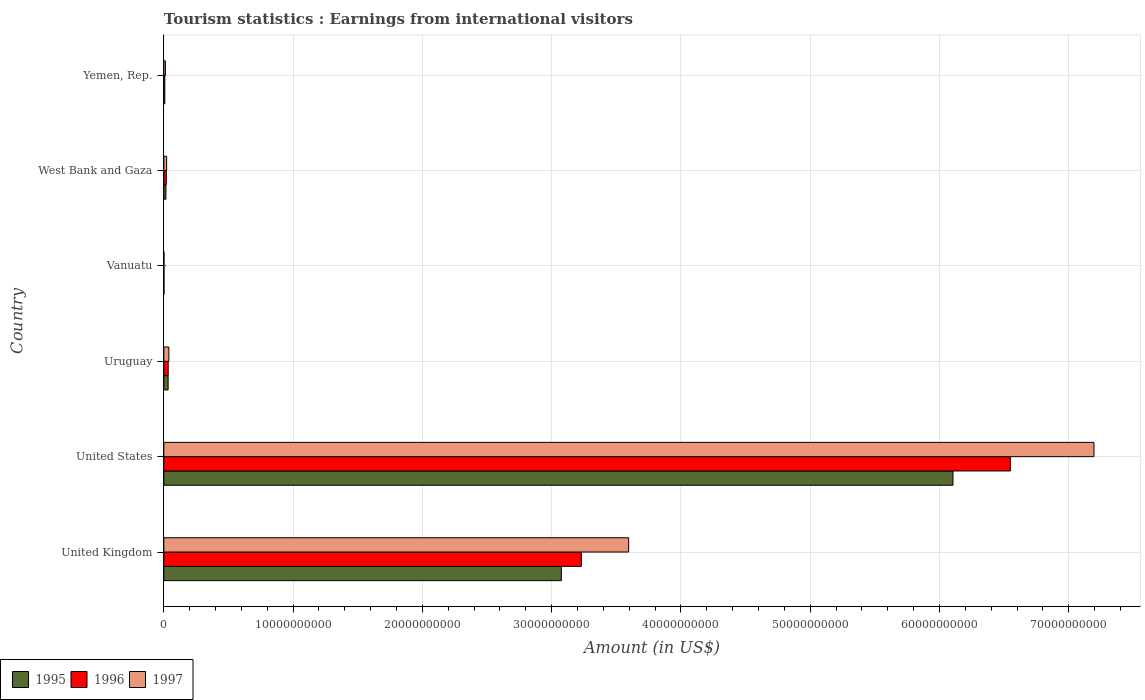How many groups of bars are there?
Make the answer very short. 6. Are the number of bars per tick equal to the number of legend labels?
Provide a short and direct response. Yes. Are the number of bars on each tick of the Y-axis equal?
Make the answer very short. Yes. How many bars are there on the 6th tick from the top?
Provide a short and direct response. 3. What is the label of the 5th group of bars from the top?
Your answer should be very brief. United States. What is the earnings from international visitors in 1995 in United Kingdom?
Your response must be concise. 3.07e+1. Across all countries, what is the maximum earnings from international visitors in 1995?
Make the answer very short. 6.10e+1. Across all countries, what is the minimum earnings from international visitors in 1996?
Offer a terse response. 1.00e+07. In which country was the earnings from international visitors in 1997 maximum?
Your answer should be very brief. United States. In which country was the earnings from international visitors in 1996 minimum?
Make the answer very short. Vanuatu. What is the total earnings from international visitors in 1996 in the graph?
Your response must be concise. 9.84e+1. What is the difference between the earnings from international visitors in 1997 in Vanuatu and that in West Bank and Gaza?
Provide a succinct answer. -2.08e+08. What is the difference between the earnings from international visitors in 1995 in United Kingdom and the earnings from international visitors in 1997 in Uruguay?
Your answer should be compact. 3.04e+1. What is the average earnings from international visitors in 1995 per country?
Give a very brief answer. 1.54e+1. What is the ratio of the earnings from international visitors in 1996 in United States to that in West Bank and Gaza?
Your answer should be very brief. 342.81. Is the earnings from international visitors in 1997 in United States less than that in Vanuatu?
Provide a short and direct response. No. What is the difference between the highest and the second highest earnings from international visitors in 1997?
Ensure brevity in your answer.  3.60e+1. What is the difference between the highest and the lowest earnings from international visitors in 1995?
Ensure brevity in your answer.  6.10e+1. In how many countries, is the earnings from international visitors in 1995 greater than the average earnings from international visitors in 1995 taken over all countries?
Your response must be concise. 2. Is the sum of the earnings from international visitors in 1997 in Vanuatu and Yemen, Rep. greater than the maximum earnings from international visitors in 1996 across all countries?
Offer a very short reply. No. Is it the case that in every country, the sum of the earnings from international visitors in 1995 and earnings from international visitors in 1997 is greater than the earnings from international visitors in 1996?
Offer a very short reply. Yes. Are all the bars in the graph horizontal?
Ensure brevity in your answer.  Yes. Are the values on the major ticks of X-axis written in scientific E-notation?
Provide a short and direct response. No. Does the graph contain grids?
Your answer should be compact. Yes. Where does the legend appear in the graph?
Your response must be concise. Bottom left. How many legend labels are there?
Offer a terse response. 3. How are the legend labels stacked?
Provide a succinct answer. Horizontal. What is the title of the graph?
Make the answer very short. Tourism statistics : Earnings from international visitors. What is the label or title of the X-axis?
Make the answer very short. Amount (in US$). What is the label or title of the Y-axis?
Give a very brief answer. Country. What is the Amount (in US$) of 1995 in United Kingdom?
Keep it short and to the point. 3.07e+1. What is the Amount (in US$) of 1996 in United Kingdom?
Ensure brevity in your answer.  3.23e+1. What is the Amount (in US$) of 1997 in United Kingdom?
Provide a succinct answer. 3.60e+1. What is the Amount (in US$) in 1995 in United States?
Your answer should be very brief. 6.10e+1. What is the Amount (in US$) in 1996 in United States?
Give a very brief answer. 6.55e+1. What is the Amount (in US$) of 1997 in United States?
Ensure brevity in your answer.  7.19e+1. What is the Amount (in US$) of 1995 in Uruguay?
Provide a short and direct response. 3.32e+08. What is the Amount (in US$) in 1996 in Uruguay?
Provide a short and direct response. 3.39e+08. What is the Amount (in US$) of 1997 in Uruguay?
Make the answer very short. 3.91e+08. What is the Amount (in US$) in 1995 in West Bank and Gaza?
Your answer should be compact. 1.62e+08. What is the Amount (in US$) of 1996 in West Bank and Gaza?
Provide a succinct answer. 1.91e+08. What is the Amount (in US$) of 1997 in West Bank and Gaza?
Offer a terse response. 2.18e+08. What is the Amount (in US$) of 1995 in Yemen, Rep.?
Provide a succinct answer. 7.60e+07. What is the Amount (in US$) of 1996 in Yemen, Rep.?
Provide a succinct answer. 7.80e+07. What is the Amount (in US$) in 1997 in Yemen, Rep.?
Your answer should be very brief. 1.24e+08. Across all countries, what is the maximum Amount (in US$) in 1995?
Your answer should be compact. 6.10e+1. Across all countries, what is the maximum Amount (in US$) of 1996?
Your response must be concise. 6.55e+1. Across all countries, what is the maximum Amount (in US$) of 1997?
Make the answer very short. 7.19e+1. Across all countries, what is the minimum Amount (in US$) in 1995?
Provide a short and direct response. 1.00e+07. Across all countries, what is the minimum Amount (in US$) of 1996?
Keep it short and to the point. 1.00e+07. What is the total Amount (in US$) in 1995 in the graph?
Offer a very short reply. 9.24e+1. What is the total Amount (in US$) of 1996 in the graph?
Make the answer very short. 9.84e+1. What is the total Amount (in US$) in 1997 in the graph?
Your answer should be compact. 1.09e+11. What is the difference between the Amount (in US$) in 1995 in United Kingdom and that in United States?
Give a very brief answer. -3.03e+1. What is the difference between the Amount (in US$) of 1996 in United Kingdom and that in United States?
Keep it short and to the point. -3.32e+1. What is the difference between the Amount (in US$) in 1997 in United Kingdom and that in United States?
Offer a very short reply. -3.60e+1. What is the difference between the Amount (in US$) in 1995 in United Kingdom and that in Uruguay?
Make the answer very short. 3.04e+1. What is the difference between the Amount (in US$) in 1996 in United Kingdom and that in Uruguay?
Offer a very short reply. 3.20e+1. What is the difference between the Amount (in US$) in 1997 in United Kingdom and that in Uruguay?
Ensure brevity in your answer.  3.56e+1. What is the difference between the Amount (in US$) of 1995 in United Kingdom and that in Vanuatu?
Provide a succinct answer. 3.07e+1. What is the difference between the Amount (in US$) of 1996 in United Kingdom and that in Vanuatu?
Ensure brevity in your answer.  3.23e+1. What is the difference between the Amount (in US$) in 1997 in United Kingdom and that in Vanuatu?
Keep it short and to the point. 3.59e+1. What is the difference between the Amount (in US$) in 1995 in United Kingdom and that in West Bank and Gaza?
Keep it short and to the point. 3.06e+1. What is the difference between the Amount (in US$) in 1996 in United Kingdom and that in West Bank and Gaza?
Keep it short and to the point. 3.21e+1. What is the difference between the Amount (in US$) of 1997 in United Kingdom and that in West Bank and Gaza?
Make the answer very short. 3.57e+1. What is the difference between the Amount (in US$) of 1995 in United Kingdom and that in Yemen, Rep.?
Your response must be concise. 3.07e+1. What is the difference between the Amount (in US$) in 1996 in United Kingdom and that in Yemen, Rep.?
Provide a short and direct response. 3.22e+1. What is the difference between the Amount (in US$) in 1997 in United Kingdom and that in Yemen, Rep.?
Your response must be concise. 3.58e+1. What is the difference between the Amount (in US$) in 1995 in United States and that in Uruguay?
Offer a terse response. 6.07e+1. What is the difference between the Amount (in US$) in 1996 in United States and that in Uruguay?
Offer a very short reply. 6.51e+1. What is the difference between the Amount (in US$) in 1997 in United States and that in Uruguay?
Ensure brevity in your answer.  7.16e+1. What is the difference between the Amount (in US$) in 1995 in United States and that in Vanuatu?
Ensure brevity in your answer.  6.10e+1. What is the difference between the Amount (in US$) in 1996 in United States and that in Vanuatu?
Offer a very short reply. 6.55e+1. What is the difference between the Amount (in US$) in 1997 in United States and that in Vanuatu?
Provide a short and direct response. 7.19e+1. What is the difference between the Amount (in US$) in 1995 in United States and that in West Bank and Gaza?
Your answer should be compact. 6.09e+1. What is the difference between the Amount (in US$) of 1996 in United States and that in West Bank and Gaza?
Your answer should be compact. 6.53e+1. What is the difference between the Amount (in US$) of 1997 in United States and that in West Bank and Gaza?
Provide a short and direct response. 7.17e+1. What is the difference between the Amount (in US$) of 1995 in United States and that in Yemen, Rep.?
Offer a terse response. 6.10e+1. What is the difference between the Amount (in US$) in 1996 in United States and that in Yemen, Rep.?
Make the answer very short. 6.54e+1. What is the difference between the Amount (in US$) of 1997 in United States and that in Yemen, Rep.?
Your answer should be very brief. 7.18e+1. What is the difference between the Amount (in US$) in 1995 in Uruguay and that in Vanuatu?
Your answer should be very brief. 3.22e+08. What is the difference between the Amount (in US$) of 1996 in Uruguay and that in Vanuatu?
Ensure brevity in your answer.  3.29e+08. What is the difference between the Amount (in US$) of 1997 in Uruguay and that in Vanuatu?
Provide a succinct answer. 3.81e+08. What is the difference between the Amount (in US$) of 1995 in Uruguay and that in West Bank and Gaza?
Your answer should be very brief. 1.70e+08. What is the difference between the Amount (in US$) in 1996 in Uruguay and that in West Bank and Gaza?
Keep it short and to the point. 1.48e+08. What is the difference between the Amount (in US$) of 1997 in Uruguay and that in West Bank and Gaza?
Your answer should be compact. 1.73e+08. What is the difference between the Amount (in US$) in 1995 in Uruguay and that in Yemen, Rep.?
Ensure brevity in your answer.  2.56e+08. What is the difference between the Amount (in US$) of 1996 in Uruguay and that in Yemen, Rep.?
Your response must be concise. 2.61e+08. What is the difference between the Amount (in US$) in 1997 in Uruguay and that in Yemen, Rep.?
Give a very brief answer. 2.67e+08. What is the difference between the Amount (in US$) in 1995 in Vanuatu and that in West Bank and Gaza?
Provide a succinct answer. -1.52e+08. What is the difference between the Amount (in US$) in 1996 in Vanuatu and that in West Bank and Gaza?
Make the answer very short. -1.81e+08. What is the difference between the Amount (in US$) in 1997 in Vanuatu and that in West Bank and Gaza?
Ensure brevity in your answer.  -2.08e+08. What is the difference between the Amount (in US$) in 1995 in Vanuatu and that in Yemen, Rep.?
Provide a succinct answer. -6.60e+07. What is the difference between the Amount (in US$) of 1996 in Vanuatu and that in Yemen, Rep.?
Keep it short and to the point. -6.80e+07. What is the difference between the Amount (in US$) in 1997 in Vanuatu and that in Yemen, Rep.?
Ensure brevity in your answer.  -1.14e+08. What is the difference between the Amount (in US$) of 1995 in West Bank and Gaza and that in Yemen, Rep.?
Give a very brief answer. 8.60e+07. What is the difference between the Amount (in US$) in 1996 in West Bank and Gaza and that in Yemen, Rep.?
Provide a succinct answer. 1.13e+08. What is the difference between the Amount (in US$) in 1997 in West Bank and Gaza and that in Yemen, Rep.?
Ensure brevity in your answer.  9.40e+07. What is the difference between the Amount (in US$) in 1995 in United Kingdom and the Amount (in US$) in 1996 in United States?
Keep it short and to the point. -3.47e+1. What is the difference between the Amount (in US$) in 1995 in United Kingdom and the Amount (in US$) in 1997 in United States?
Keep it short and to the point. -4.12e+1. What is the difference between the Amount (in US$) in 1996 in United Kingdom and the Amount (in US$) in 1997 in United States?
Make the answer very short. -3.97e+1. What is the difference between the Amount (in US$) of 1995 in United Kingdom and the Amount (in US$) of 1996 in Uruguay?
Offer a very short reply. 3.04e+1. What is the difference between the Amount (in US$) of 1995 in United Kingdom and the Amount (in US$) of 1997 in Uruguay?
Provide a succinct answer. 3.04e+1. What is the difference between the Amount (in US$) of 1996 in United Kingdom and the Amount (in US$) of 1997 in Uruguay?
Give a very brief answer. 3.19e+1. What is the difference between the Amount (in US$) of 1995 in United Kingdom and the Amount (in US$) of 1996 in Vanuatu?
Your answer should be very brief. 3.07e+1. What is the difference between the Amount (in US$) of 1995 in United Kingdom and the Amount (in US$) of 1997 in Vanuatu?
Ensure brevity in your answer.  3.07e+1. What is the difference between the Amount (in US$) of 1996 in United Kingdom and the Amount (in US$) of 1997 in Vanuatu?
Your answer should be compact. 3.23e+1. What is the difference between the Amount (in US$) of 1995 in United Kingdom and the Amount (in US$) of 1996 in West Bank and Gaza?
Keep it short and to the point. 3.06e+1. What is the difference between the Amount (in US$) in 1995 in United Kingdom and the Amount (in US$) in 1997 in West Bank and Gaza?
Your answer should be very brief. 3.05e+1. What is the difference between the Amount (in US$) in 1996 in United Kingdom and the Amount (in US$) in 1997 in West Bank and Gaza?
Your response must be concise. 3.21e+1. What is the difference between the Amount (in US$) of 1995 in United Kingdom and the Amount (in US$) of 1996 in Yemen, Rep.?
Provide a short and direct response. 3.07e+1. What is the difference between the Amount (in US$) of 1995 in United Kingdom and the Amount (in US$) of 1997 in Yemen, Rep.?
Provide a short and direct response. 3.06e+1. What is the difference between the Amount (in US$) of 1996 in United Kingdom and the Amount (in US$) of 1997 in Yemen, Rep.?
Give a very brief answer. 3.22e+1. What is the difference between the Amount (in US$) in 1995 in United States and the Amount (in US$) in 1996 in Uruguay?
Offer a terse response. 6.07e+1. What is the difference between the Amount (in US$) of 1995 in United States and the Amount (in US$) of 1997 in Uruguay?
Ensure brevity in your answer.  6.07e+1. What is the difference between the Amount (in US$) in 1996 in United States and the Amount (in US$) in 1997 in Uruguay?
Offer a very short reply. 6.51e+1. What is the difference between the Amount (in US$) of 1995 in United States and the Amount (in US$) of 1996 in Vanuatu?
Make the answer very short. 6.10e+1. What is the difference between the Amount (in US$) of 1995 in United States and the Amount (in US$) of 1997 in Vanuatu?
Your answer should be very brief. 6.10e+1. What is the difference between the Amount (in US$) of 1996 in United States and the Amount (in US$) of 1997 in Vanuatu?
Keep it short and to the point. 6.55e+1. What is the difference between the Amount (in US$) of 1995 in United States and the Amount (in US$) of 1996 in West Bank and Gaza?
Keep it short and to the point. 6.09e+1. What is the difference between the Amount (in US$) of 1995 in United States and the Amount (in US$) of 1997 in West Bank and Gaza?
Your response must be concise. 6.08e+1. What is the difference between the Amount (in US$) of 1996 in United States and the Amount (in US$) of 1997 in West Bank and Gaza?
Your response must be concise. 6.53e+1. What is the difference between the Amount (in US$) in 1995 in United States and the Amount (in US$) in 1996 in Yemen, Rep.?
Provide a short and direct response. 6.10e+1. What is the difference between the Amount (in US$) of 1995 in United States and the Amount (in US$) of 1997 in Yemen, Rep.?
Your response must be concise. 6.09e+1. What is the difference between the Amount (in US$) of 1996 in United States and the Amount (in US$) of 1997 in Yemen, Rep.?
Offer a very short reply. 6.54e+1. What is the difference between the Amount (in US$) of 1995 in Uruguay and the Amount (in US$) of 1996 in Vanuatu?
Your answer should be very brief. 3.22e+08. What is the difference between the Amount (in US$) of 1995 in Uruguay and the Amount (in US$) of 1997 in Vanuatu?
Keep it short and to the point. 3.22e+08. What is the difference between the Amount (in US$) in 1996 in Uruguay and the Amount (in US$) in 1997 in Vanuatu?
Provide a succinct answer. 3.29e+08. What is the difference between the Amount (in US$) in 1995 in Uruguay and the Amount (in US$) in 1996 in West Bank and Gaza?
Your answer should be very brief. 1.41e+08. What is the difference between the Amount (in US$) in 1995 in Uruguay and the Amount (in US$) in 1997 in West Bank and Gaza?
Keep it short and to the point. 1.14e+08. What is the difference between the Amount (in US$) of 1996 in Uruguay and the Amount (in US$) of 1997 in West Bank and Gaza?
Give a very brief answer. 1.21e+08. What is the difference between the Amount (in US$) of 1995 in Uruguay and the Amount (in US$) of 1996 in Yemen, Rep.?
Offer a terse response. 2.54e+08. What is the difference between the Amount (in US$) in 1995 in Uruguay and the Amount (in US$) in 1997 in Yemen, Rep.?
Provide a succinct answer. 2.08e+08. What is the difference between the Amount (in US$) in 1996 in Uruguay and the Amount (in US$) in 1997 in Yemen, Rep.?
Offer a very short reply. 2.15e+08. What is the difference between the Amount (in US$) of 1995 in Vanuatu and the Amount (in US$) of 1996 in West Bank and Gaza?
Ensure brevity in your answer.  -1.81e+08. What is the difference between the Amount (in US$) of 1995 in Vanuatu and the Amount (in US$) of 1997 in West Bank and Gaza?
Make the answer very short. -2.08e+08. What is the difference between the Amount (in US$) of 1996 in Vanuatu and the Amount (in US$) of 1997 in West Bank and Gaza?
Offer a terse response. -2.08e+08. What is the difference between the Amount (in US$) in 1995 in Vanuatu and the Amount (in US$) in 1996 in Yemen, Rep.?
Your response must be concise. -6.80e+07. What is the difference between the Amount (in US$) in 1995 in Vanuatu and the Amount (in US$) in 1997 in Yemen, Rep.?
Provide a succinct answer. -1.14e+08. What is the difference between the Amount (in US$) in 1996 in Vanuatu and the Amount (in US$) in 1997 in Yemen, Rep.?
Keep it short and to the point. -1.14e+08. What is the difference between the Amount (in US$) of 1995 in West Bank and Gaza and the Amount (in US$) of 1996 in Yemen, Rep.?
Offer a terse response. 8.40e+07. What is the difference between the Amount (in US$) of 1995 in West Bank and Gaza and the Amount (in US$) of 1997 in Yemen, Rep.?
Offer a terse response. 3.80e+07. What is the difference between the Amount (in US$) of 1996 in West Bank and Gaza and the Amount (in US$) of 1997 in Yemen, Rep.?
Keep it short and to the point. 6.70e+07. What is the average Amount (in US$) of 1995 per country?
Ensure brevity in your answer.  1.54e+1. What is the average Amount (in US$) of 1996 per country?
Provide a short and direct response. 1.64e+1. What is the average Amount (in US$) in 1997 per country?
Offer a very short reply. 1.81e+1. What is the difference between the Amount (in US$) in 1995 and Amount (in US$) in 1996 in United Kingdom?
Give a very brief answer. -1.55e+09. What is the difference between the Amount (in US$) of 1995 and Amount (in US$) of 1997 in United Kingdom?
Your answer should be very brief. -5.20e+09. What is the difference between the Amount (in US$) in 1996 and Amount (in US$) in 1997 in United Kingdom?
Provide a succinct answer. -3.66e+09. What is the difference between the Amount (in US$) in 1995 and Amount (in US$) in 1996 in United States?
Your response must be concise. -4.44e+09. What is the difference between the Amount (in US$) in 1995 and Amount (in US$) in 1997 in United States?
Your answer should be very brief. -1.09e+1. What is the difference between the Amount (in US$) in 1996 and Amount (in US$) in 1997 in United States?
Provide a short and direct response. -6.47e+09. What is the difference between the Amount (in US$) in 1995 and Amount (in US$) in 1996 in Uruguay?
Your answer should be very brief. -7.00e+06. What is the difference between the Amount (in US$) in 1995 and Amount (in US$) in 1997 in Uruguay?
Offer a terse response. -5.90e+07. What is the difference between the Amount (in US$) of 1996 and Amount (in US$) of 1997 in Uruguay?
Offer a very short reply. -5.20e+07. What is the difference between the Amount (in US$) in 1996 and Amount (in US$) in 1997 in Vanuatu?
Your response must be concise. 0. What is the difference between the Amount (in US$) of 1995 and Amount (in US$) of 1996 in West Bank and Gaza?
Your response must be concise. -2.90e+07. What is the difference between the Amount (in US$) of 1995 and Amount (in US$) of 1997 in West Bank and Gaza?
Offer a very short reply. -5.60e+07. What is the difference between the Amount (in US$) of 1996 and Amount (in US$) of 1997 in West Bank and Gaza?
Keep it short and to the point. -2.70e+07. What is the difference between the Amount (in US$) in 1995 and Amount (in US$) in 1996 in Yemen, Rep.?
Provide a short and direct response. -2.00e+06. What is the difference between the Amount (in US$) in 1995 and Amount (in US$) in 1997 in Yemen, Rep.?
Your answer should be very brief. -4.80e+07. What is the difference between the Amount (in US$) in 1996 and Amount (in US$) in 1997 in Yemen, Rep.?
Your response must be concise. -4.60e+07. What is the ratio of the Amount (in US$) of 1995 in United Kingdom to that in United States?
Ensure brevity in your answer.  0.5. What is the ratio of the Amount (in US$) in 1996 in United Kingdom to that in United States?
Provide a short and direct response. 0.49. What is the ratio of the Amount (in US$) in 1997 in United Kingdom to that in United States?
Provide a short and direct response. 0.5. What is the ratio of the Amount (in US$) in 1995 in United Kingdom to that in Uruguay?
Keep it short and to the point. 92.62. What is the ratio of the Amount (in US$) of 1996 in United Kingdom to that in Uruguay?
Offer a terse response. 95.27. What is the ratio of the Amount (in US$) of 1997 in United Kingdom to that in Uruguay?
Ensure brevity in your answer.  91.95. What is the ratio of the Amount (in US$) in 1995 in United Kingdom to that in Vanuatu?
Provide a succinct answer. 3074.9. What is the ratio of the Amount (in US$) of 1996 in United Kingdom to that in Vanuatu?
Provide a succinct answer. 3229.79. What is the ratio of the Amount (in US$) of 1997 in United Kingdom to that in Vanuatu?
Your response must be concise. 3595.4. What is the ratio of the Amount (in US$) of 1995 in United Kingdom to that in West Bank and Gaza?
Your answer should be compact. 189.81. What is the ratio of the Amount (in US$) in 1996 in United Kingdom to that in West Bank and Gaza?
Offer a terse response. 169.1. What is the ratio of the Amount (in US$) in 1997 in United Kingdom to that in West Bank and Gaza?
Keep it short and to the point. 164.93. What is the ratio of the Amount (in US$) in 1995 in United Kingdom to that in Yemen, Rep.?
Make the answer very short. 404.59. What is the ratio of the Amount (in US$) in 1996 in United Kingdom to that in Yemen, Rep.?
Provide a short and direct response. 414.08. What is the ratio of the Amount (in US$) in 1997 in United Kingdom to that in Yemen, Rep.?
Provide a short and direct response. 289.95. What is the ratio of the Amount (in US$) in 1995 in United States to that in Uruguay?
Offer a very short reply. 183.86. What is the ratio of the Amount (in US$) of 1996 in United States to that in Uruguay?
Make the answer very short. 193.15. What is the ratio of the Amount (in US$) in 1997 in United States to that in Uruguay?
Your answer should be very brief. 184.01. What is the ratio of the Amount (in US$) of 1995 in United States to that in Vanuatu?
Give a very brief answer. 6104.2. What is the ratio of the Amount (in US$) of 1996 in United States to that in Vanuatu?
Keep it short and to the point. 6547.7. What is the ratio of the Amount (in US$) in 1997 in United States to that in Vanuatu?
Ensure brevity in your answer.  7194.8. What is the ratio of the Amount (in US$) in 1995 in United States to that in West Bank and Gaza?
Your response must be concise. 376.8. What is the ratio of the Amount (in US$) of 1996 in United States to that in West Bank and Gaza?
Your response must be concise. 342.81. What is the ratio of the Amount (in US$) in 1997 in United States to that in West Bank and Gaza?
Offer a very short reply. 330.04. What is the ratio of the Amount (in US$) of 1995 in United States to that in Yemen, Rep.?
Your response must be concise. 803.18. What is the ratio of the Amount (in US$) in 1996 in United States to that in Yemen, Rep.?
Your response must be concise. 839.45. What is the ratio of the Amount (in US$) in 1997 in United States to that in Yemen, Rep.?
Give a very brief answer. 580.23. What is the ratio of the Amount (in US$) of 1995 in Uruguay to that in Vanuatu?
Your response must be concise. 33.2. What is the ratio of the Amount (in US$) in 1996 in Uruguay to that in Vanuatu?
Make the answer very short. 33.9. What is the ratio of the Amount (in US$) in 1997 in Uruguay to that in Vanuatu?
Your answer should be compact. 39.1. What is the ratio of the Amount (in US$) in 1995 in Uruguay to that in West Bank and Gaza?
Your answer should be compact. 2.05. What is the ratio of the Amount (in US$) of 1996 in Uruguay to that in West Bank and Gaza?
Offer a very short reply. 1.77. What is the ratio of the Amount (in US$) of 1997 in Uruguay to that in West Bank and Gaza?
Ensure brevity in your answer.  1.79. What is the ratio of the Amount (in US$) of 1995 in Uruguay to that in Yemen, Rep.?
Provide a short and direct response. 4.37. What is the ratio of the Amount (in US$) of 1996 in Uruguay to that in Yemen, Rep.?
Provide a short and direct response. 4.35. What is the ratio of the Amount (in US$) in 1997 in Uruguay to that in Yemen, Rep.?
Your response must be concise. 3.15. What is the ratio of the Amount (in US$) of 1995 in Vanuatu to that in West Bank and Gaza?
Offer a very short reply. 0.06. What is the ratio of the Amount (in US$) of 1996 in Vanuatu to that in West Bank and Gaza?
Provide a succinct answer. 0.05. What is the ratio of the Amount (in US$) in 1997 in Vanuatu to that in West Bank and Gaza?
Provide a short and direct response. 0.05. What is the ratio of the Amount (in US$) of 1995 in Vanuatu to that in Yemen, Rep.?
Provide a succinct answer. 0.13. What is the ratio of the Amount (in US$) of 1996 in Vanuatu to that in Yemen, Rep.?
Offer a terse response. 0.13. What is the ratio of the Amount (in US$) in 1997 in Vanuatu to that in Yemen, Rep.?
Offer a terse response. 0.08. What is the ratio of the Amount (in US$) in 1995 in West Bank and Gaza to that in Yemen, Rep.?
Make the answer very short. 2.13. What is the ratio of the Amount (in US$) of 1996 in West Bank and Gaza to that in Yemen, Rep.?
Provide a succinct answer. 2.45. What is the ratio of the Amount (in US$) in 1997 in West Bank and Gaza to that in Yemen, Rep.?
Offer a terse response. 1.76. What is the difference between the highest and the second highest Amount (in US$) of 1995?
Your answer should be compact. 3.03e+1. What is the difference between the highest and the second highest Amount (in US$) of 1996?
Ensure brevity in your answer.  3.32e+1. What is the difference between the highest and the second highest Amount (in US$) of 1997?
Provide a succinct answer. 3.60e+1. What is the difference between the highest and the lowest Amount (in US$) in 1995?
Provide a succinct answer. 6.10e+1. What is the difference between the highest and the lowest Amount (in US$) in 1996?
Offer a terse response. 6.55e+1. What is the difference between the highest and the lowest Amount (in US$) in 1997?
Keep it short and to the point. 7.19e+1. 